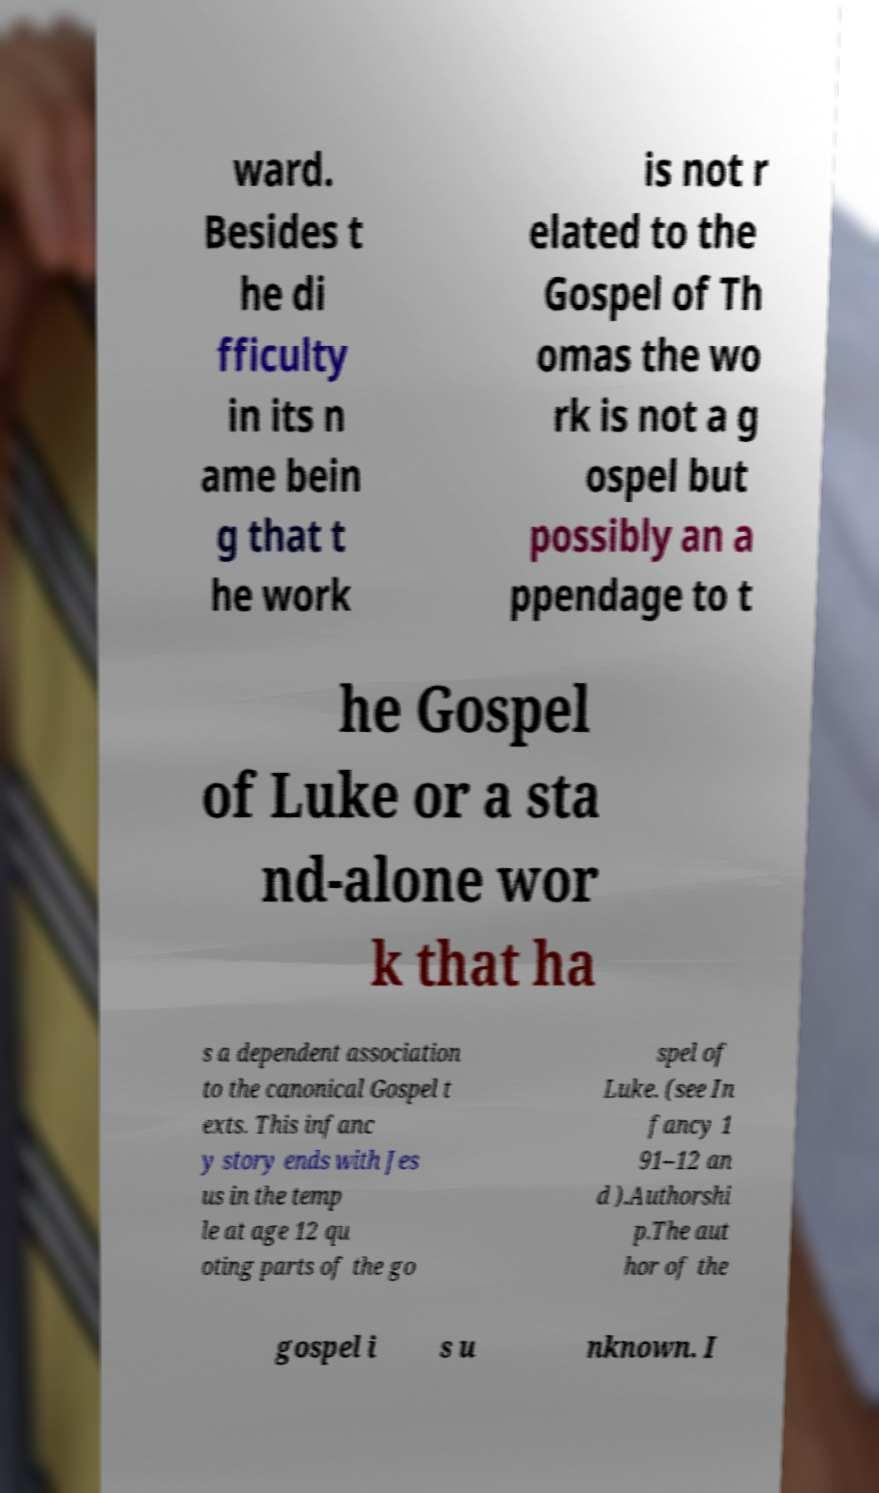Can you accurately transcribe the text from the provided image for me? ward. Besides t he di fficulty in its n ame bein g that t he work is not r elated to the Gospel of Th omas the wo rk is not a g ospel but possibly an a ppendage to t he Gospel of Luke or a sta nd-alone wor k that ha s a dependent association to the canonical Gospel t exts. This infanc y story ends with Jes us in the temp le at age 12 qu oting parts of the go spel of Luke. (see In fancy 1 91–12 an d ).Authorshi p.The aut hor of the gospel i s u nknown. I 